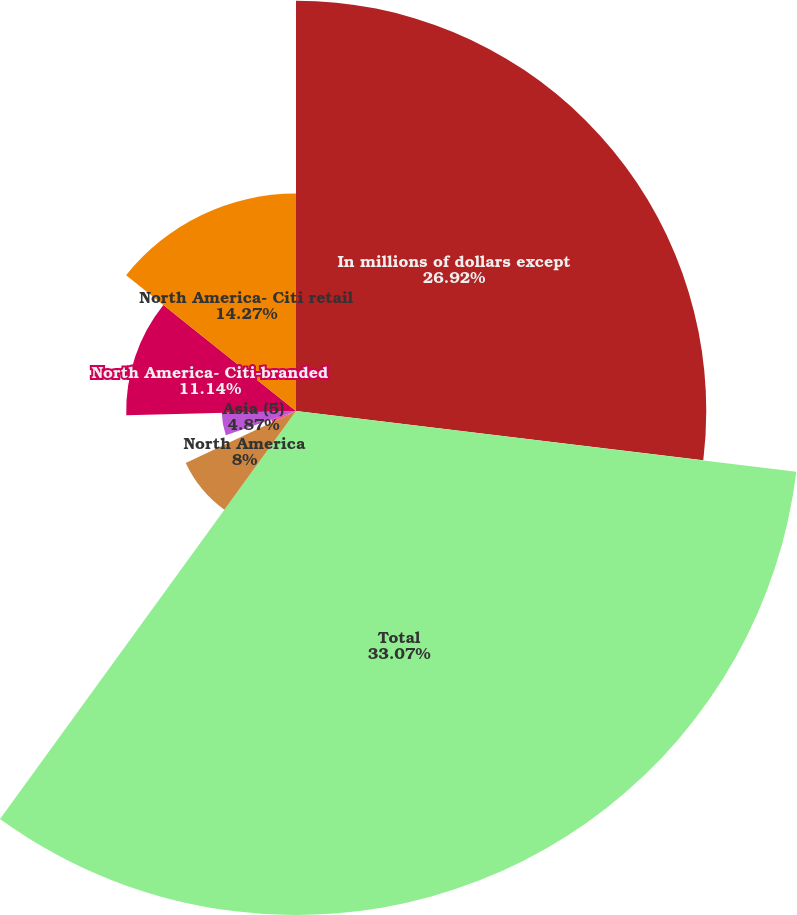Convert chart. <chart><loc_0><loc_0><loc_500><loc_500><pie_chart><fcel>In millions of dollars except<fcel>Total<fcel>North America<fcel>Latin America<fcel>Asia (5)<fcel>North America- Citi-branded<fcel>North America- Citi retail<nl><fcel>26.92%<fcel>33.07%<fcel>8.0%<fcel>1.73%<fcel>4.87%<fcel>11.14%<fcel>14.27%<nl></chart> 